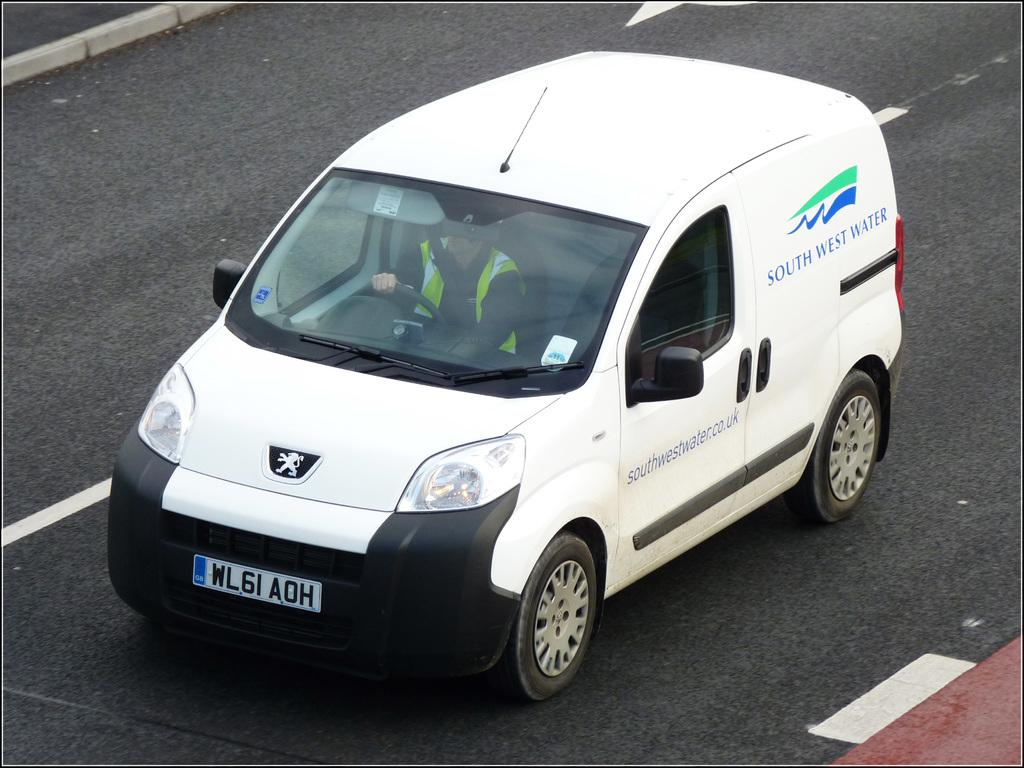What is the main subject of the image? The main subject of the image is a car. Where is the car located in the image? The car is on a road. What type of cart is being pushed by the car's knee in the image? There is no cart or knee present in the image; it only features a car on a road. 